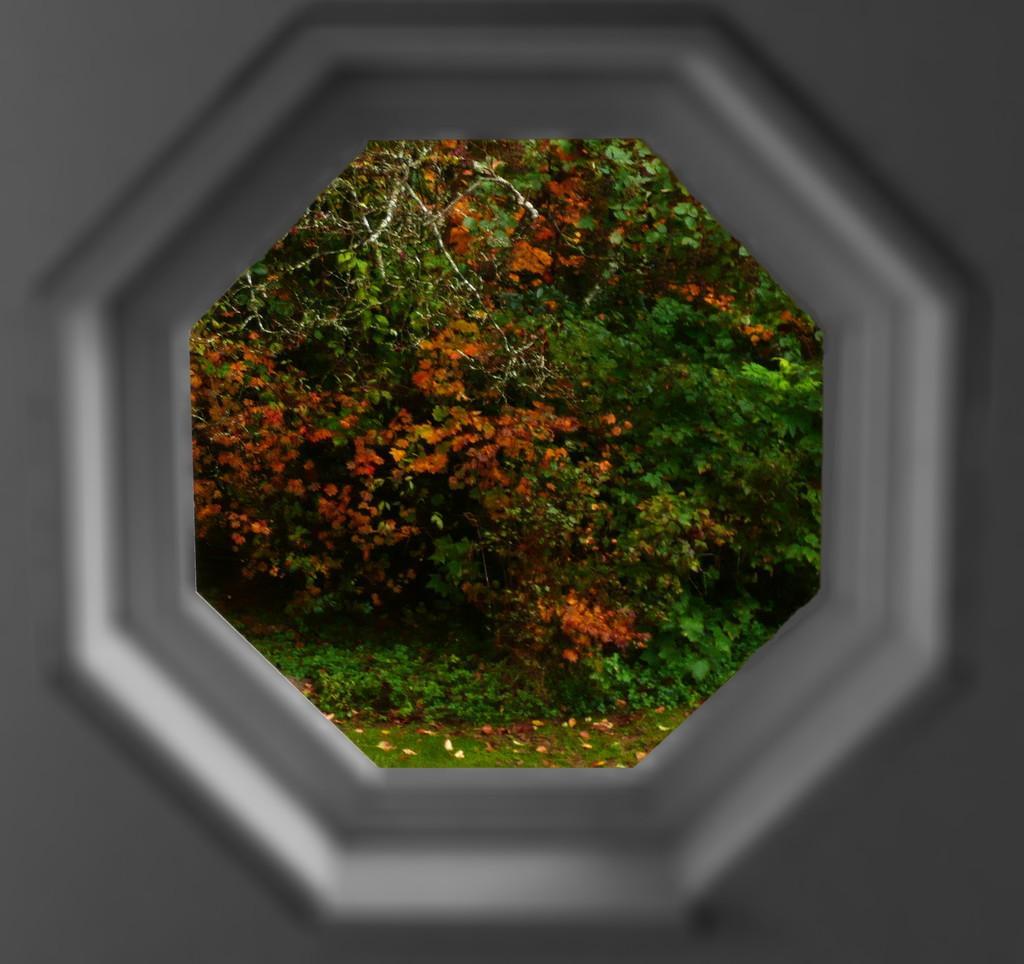How would you summarize this image in a sentence or two? In this image, we can see some trees and plants through hexagon. 